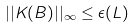Convert formula to latex. <formula><loc_0><loc_0><loc_500><loc_500>| | K ( B ) | | _ { \infty } \leq \epsilon ( L )</formula> 